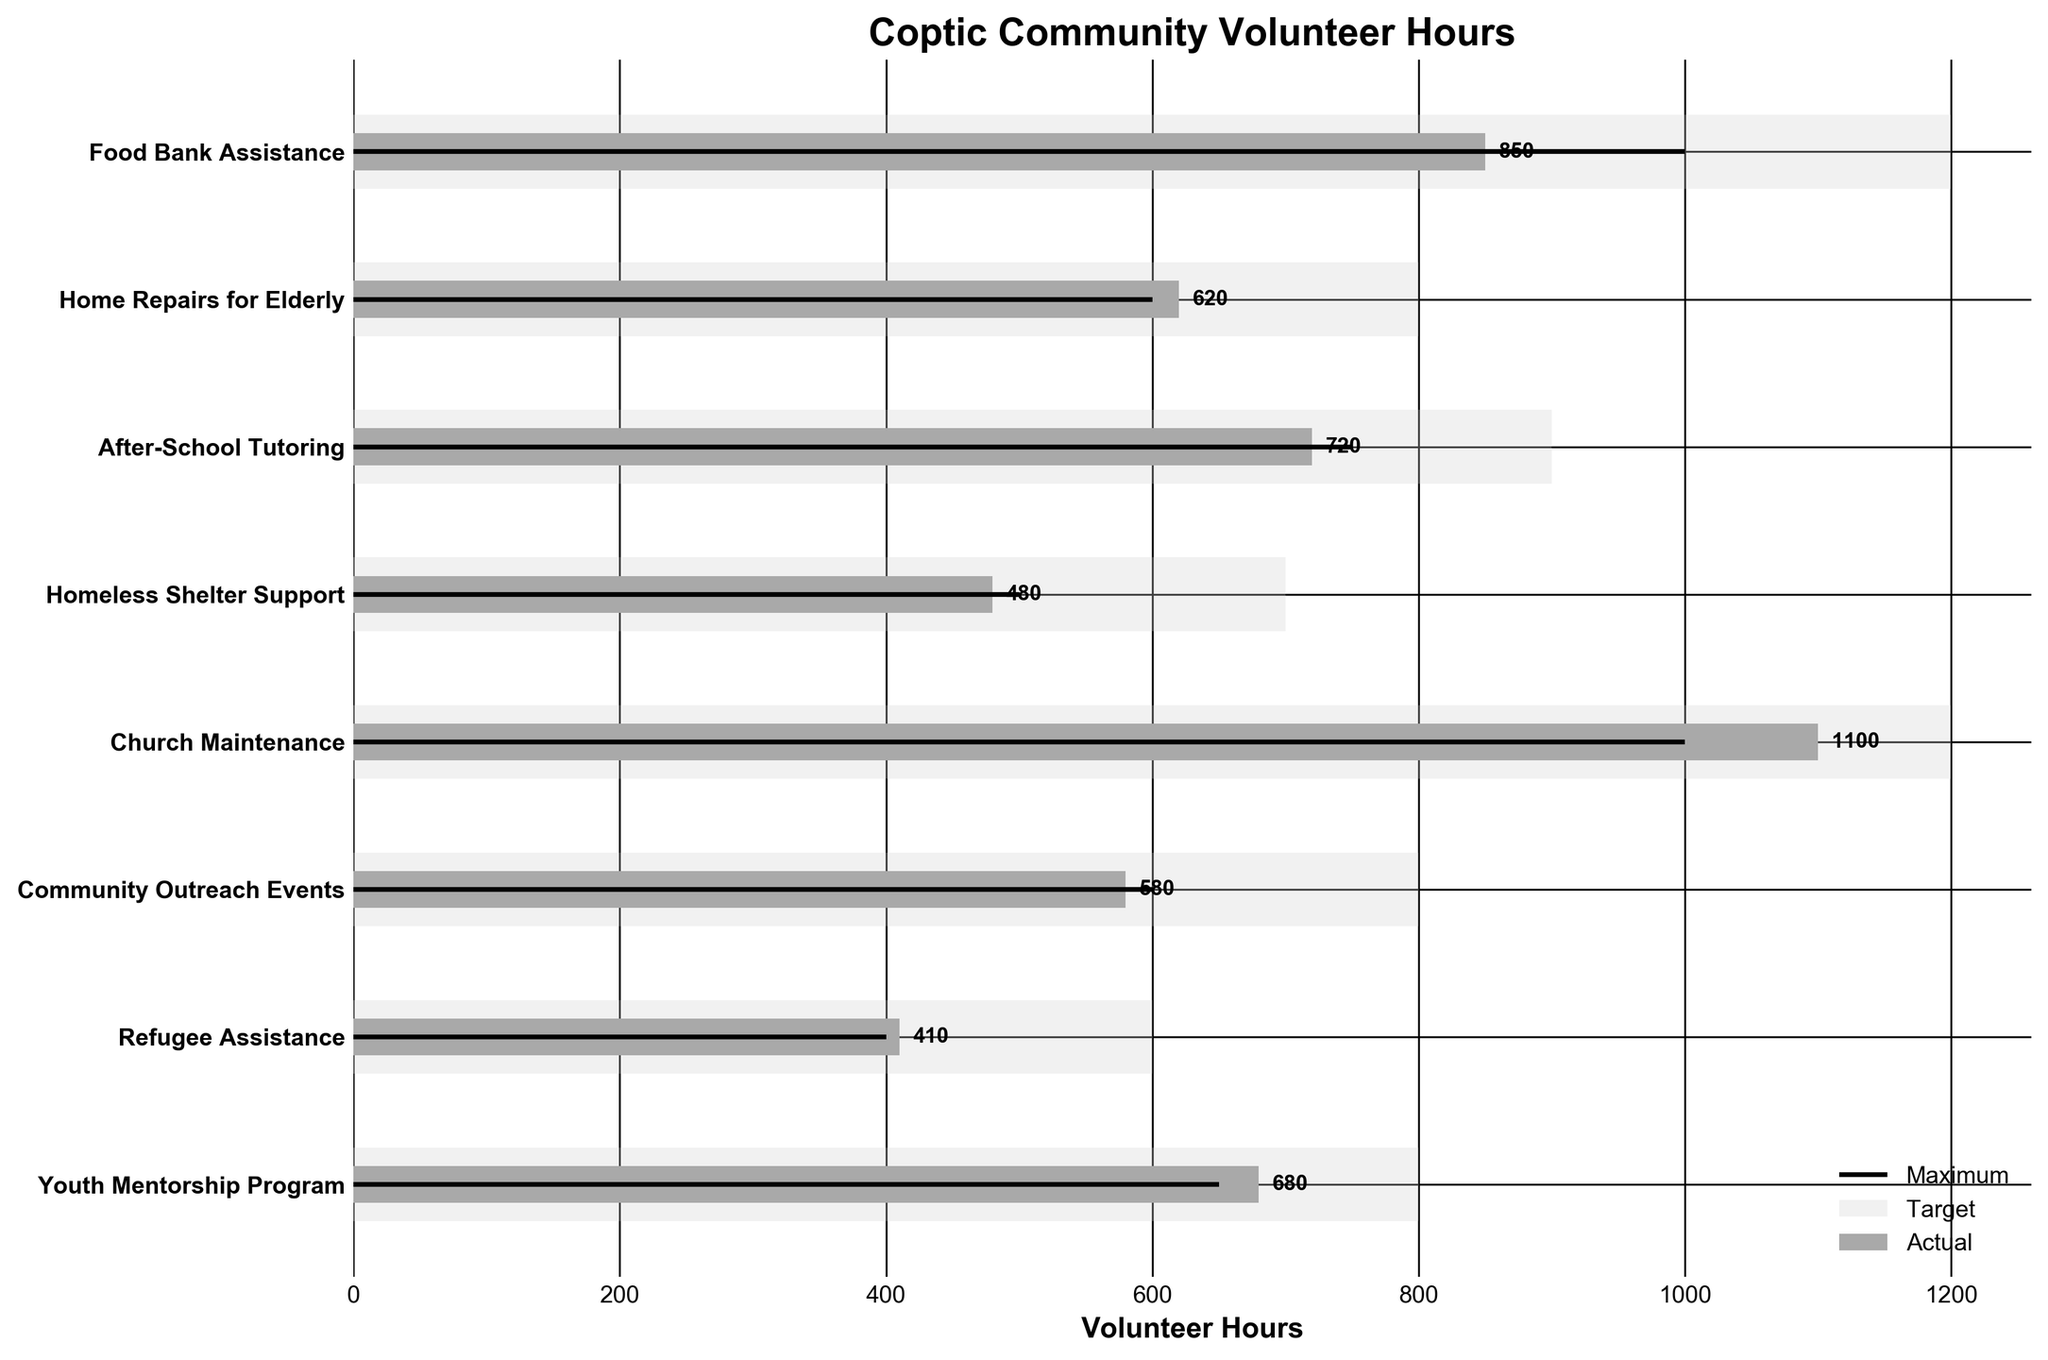What is the title of the figure? The title of the figure can be found at the top of the plot where it summarizes the main topic or purpose of the data being visualized. Here, it states the focus on the hours volunteered by the Coptic community.
Answer: Coptic Community Volunteer Hours How many categories are shown in the plot? To find the number of categories, count the number of distinct bars or labels on the vertical axis. Each category represents a different volunteer activity.
Answer: 8 Which category had the highest actual volunteer hours? Compare the actual volunteer hours for each category. The tallest dark grey bar on the plot represents the highest actual volunteer hours.
Answer: Church Maintenance What's the difference between the actual and target volunteer hours for Food Bank Assistance? Find the "Actual" value and subtract the "Target" value for the Food Bank Assistance category. Actual is 850 and Target is 1000, so the difference is 1000 - 850 = 150 hours short.
Answer: 150 hours short Which categories met or exceeded their target volunteer hours? Look for categories where the dark grey bar (actual) reaches or exceeds the black line (target).
Answer: Home Repairs for Elderly, Refugee Assistance, Youth Mentorship Program, Church Maintenance What is the average target volunteer hours across all categories? Sum the target volunteer hours for all categories and divide by the number of categories. (1000 + 600 + 750 + 500 + 1000 + 600 + 400 + 650) / 8 = 5625 / 8 = 703.125
Answer: 703.125 How many hours more than the target did Church Maintenance receive? Find the "Actual" value and subtract the "Target" value for Church Maintenance. Actual is 1100 and Target is 1000, so the difference is 1100 - 1000 = 100 hours.
Answer: 100 hours Compare the actual volunteer hours for After-School Tutoring and Homeless Shelter Support. Which one is greater? Compare the lengths of the dark grey bars for both categories. The longer bar represents the higher actual volunteer hours.
Answer: After-School Tutoring What is the maximum volunteer hours target set for any category? Look for the highest value among the maximum (maximum) targets set across all categories. The longest light grey background bar corresponds to the highest target.
Answer: 1200 By how many hours did the Youth Mentorship Program exceed its target? Find the "Actual" value and subtract the "Target" value for Youth Mentorship Program. Actual is 680 and Target is 650, so the difference is 680 - 650 = 30 hours.
Answer: 30 hours 